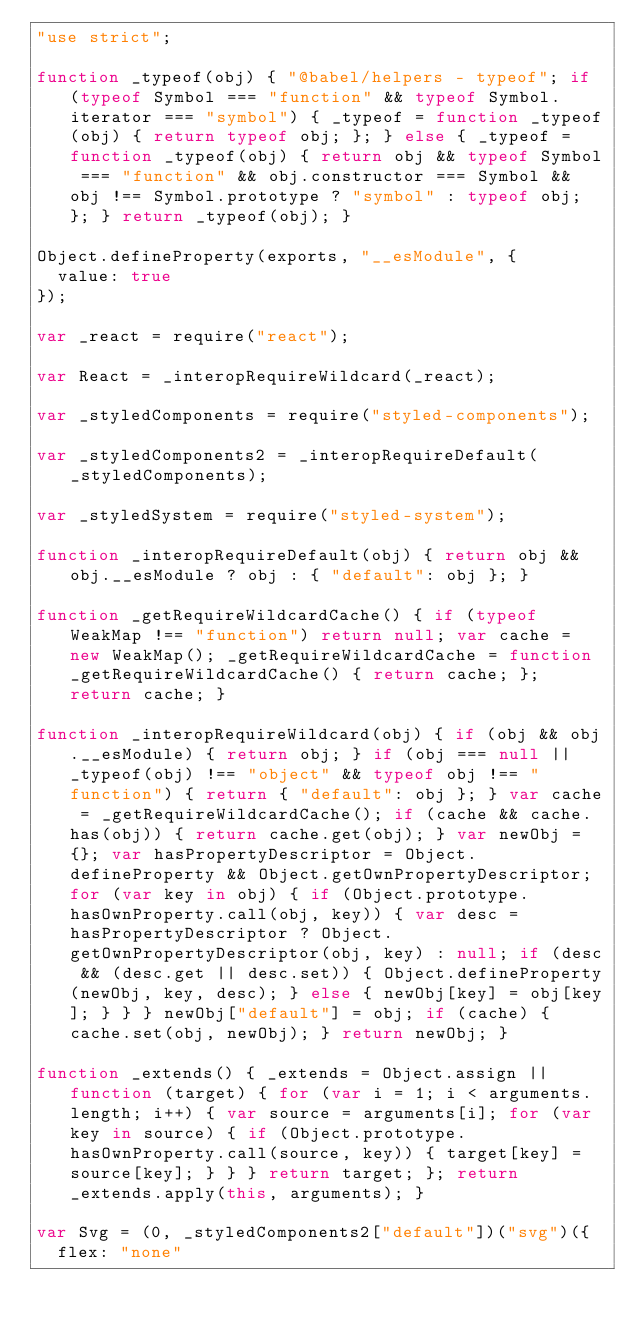<code> <loc_0><loc_0><loc_500><loc_500><_JavaScript_>"use strict";

function _typeof(obj) { "@babel/helpers - typeof"; if (typeof Symbol === "function" && typeof Symbol.iterator === "symbol") { _typeof = function _typeof(obj) { return typeof obj; }; } else { _typeof = function _typeof(obj) { return obj && typeof Symbol === "function" && obj.constructor === Symbol && obj !== Symbol.prototype ? "symbol" : typeof obj; }; } return _typeof(obj); }

Object.defineProperty(exports, "__esModule", {
  value: true
});

var _react = require("react");

var React = _interopRequireWildcard(_react);

var _styledComponents = require("styled-components");

var _styledComponents2 = _interopRequireDefault(_styledComponents);

var _styledSystem = require("styled-system");

function _interopRequireDefault(obj) { return obj && obj.__esModule ? obj : { "default": obj }; }

function _getRequireWildcardCache() { if (typeof WeakMap !== "function") return null; var cache = new WeakMap(); _getRequireWildcardCache = function _getRequireWildcardCache() { return cache; }; return cache; }

function _interopRequireWildcard(obj) { if (obj && obj.__esModule) { return obj; } if (obj === null || _typeof(obj) !== "object" && typeof obj !== "function") { return { "default": obj }; } var cache = _getRequireWildcardCache(); if (cache && cache.has(obj)) { return cache.get(obj); } var newObj = {}; var hasPropertyDescriptor = Object.defineProperty && Object.getOwnPropertyDescriptor; for (var key in obj) { if (Object.prototype.hasOwnProperty.call(obj, key)) { var desc = hasPropertyDescriptor ? Object.getOwnPropertyDescriptor(obj, key) : null; if (desc && (desc.get || desc.set)) { Object.defineProperty(newObj, key, desc); } else { newObj[key] = obj[key]; } } } newObj["default"] = obj; if (cache) { cache.set(obj, newObj); } return newObj; }

function _extends() { _extends = Object.assign || function (target) { for (var i = 1; i < arguments.length; i++) { var source = arguments[i]; for (var key in source) { if (Object.prototype.hasOwnProperty.call(source, key)) { target[key] = source[key]; } } } return target; }; return _extends.apply(this, arguments); }

var Svg = (0, _styledComponents2["default"])("svg")({
  flex: "none"</code> 